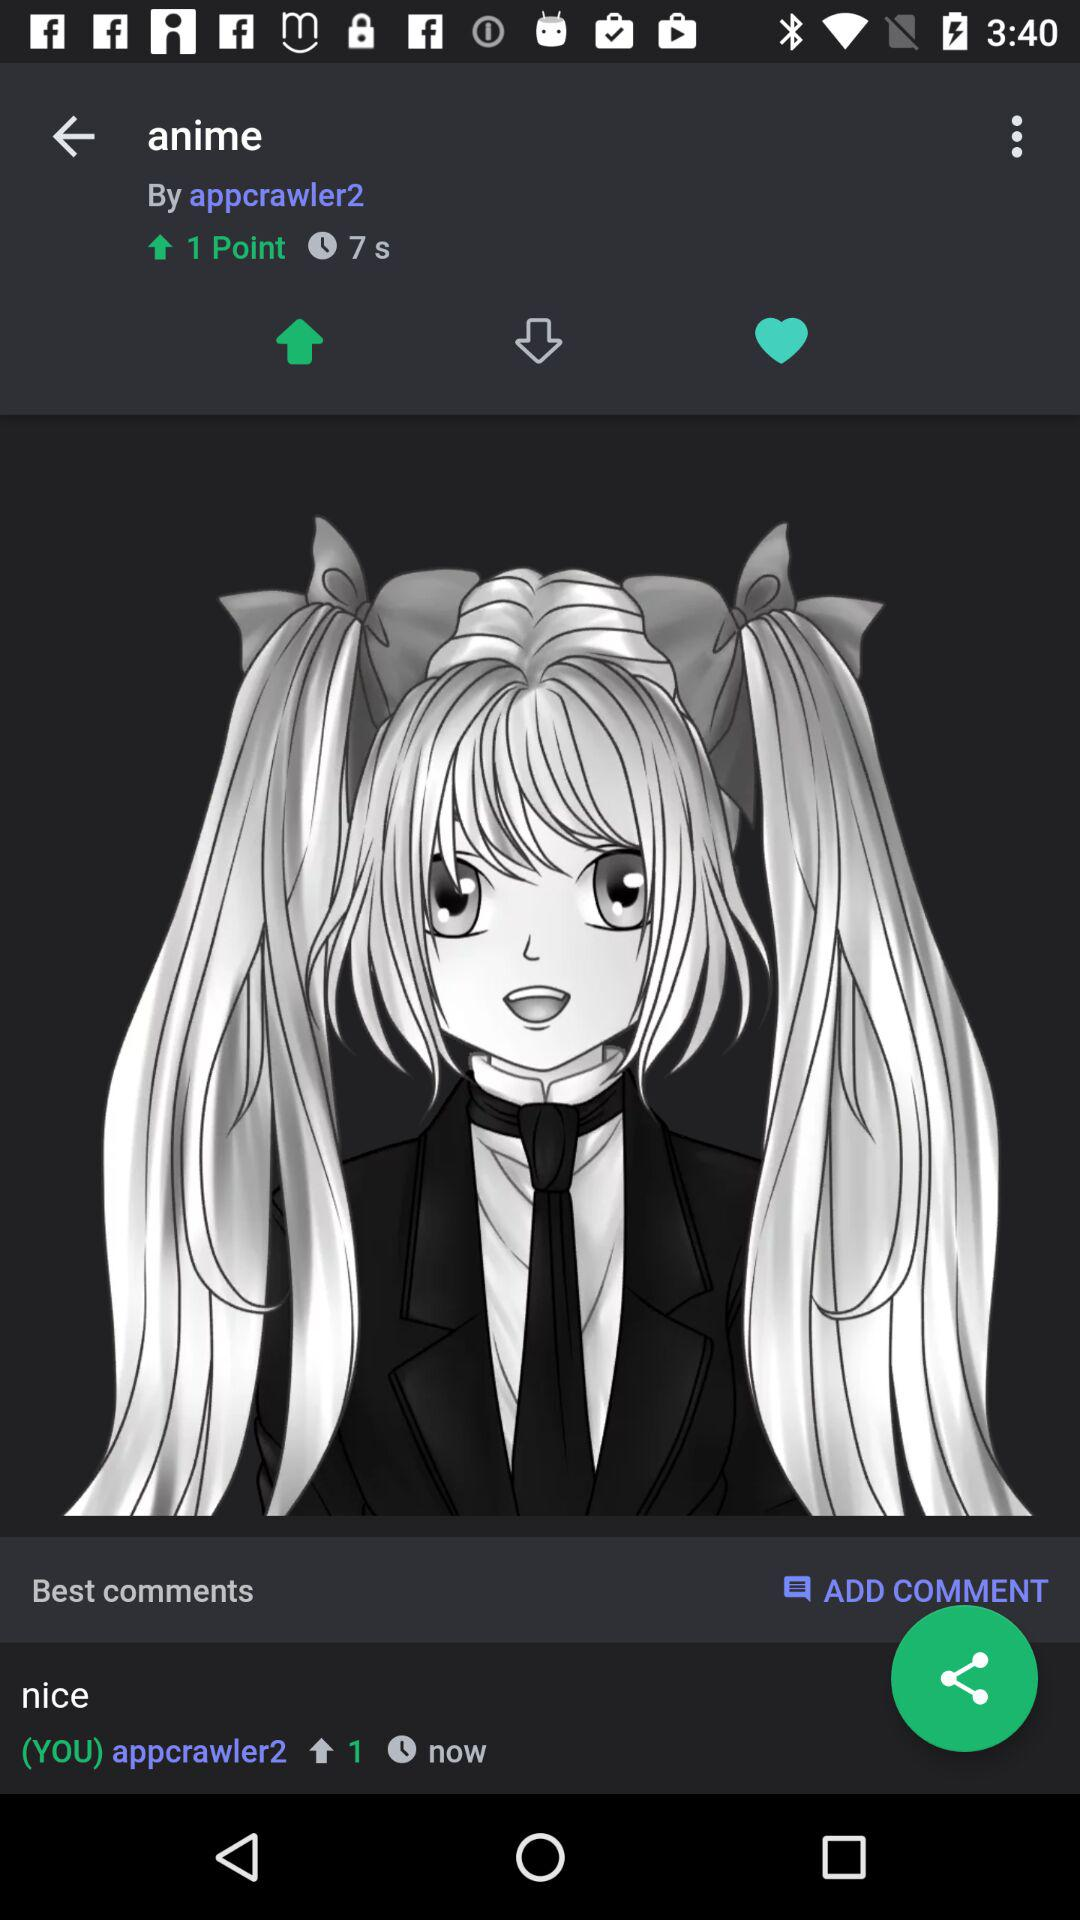How many downvotes are there?
When the provided information is insufficient, respond with <no answer>. <no answer> 